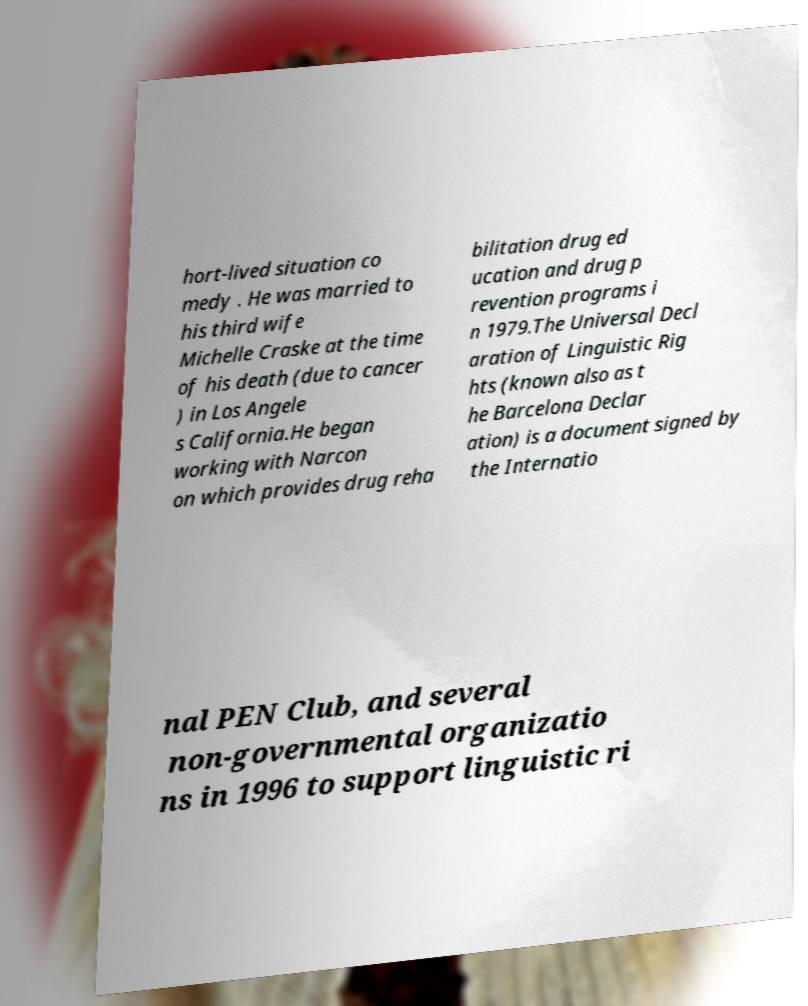There's text embedded in this image that I need extracted. Can you transcribe it verbatim? hort-lived situation co medy . He was married to his third wife Michelle Craske at the time of his death (due to cancer ) in Los Angele s California.He began working with Narcon on which provides drug reha bilitation drug ed ucation and drug p revention programs i n 1979.The Universal Decl aration of Linguistic Rig hts (known also as t he Barcelona Declar ation) is a document signed by the Internatio nal PEN Club, and several non-governmental organizatio ns in 1996 to support linguistic ri 